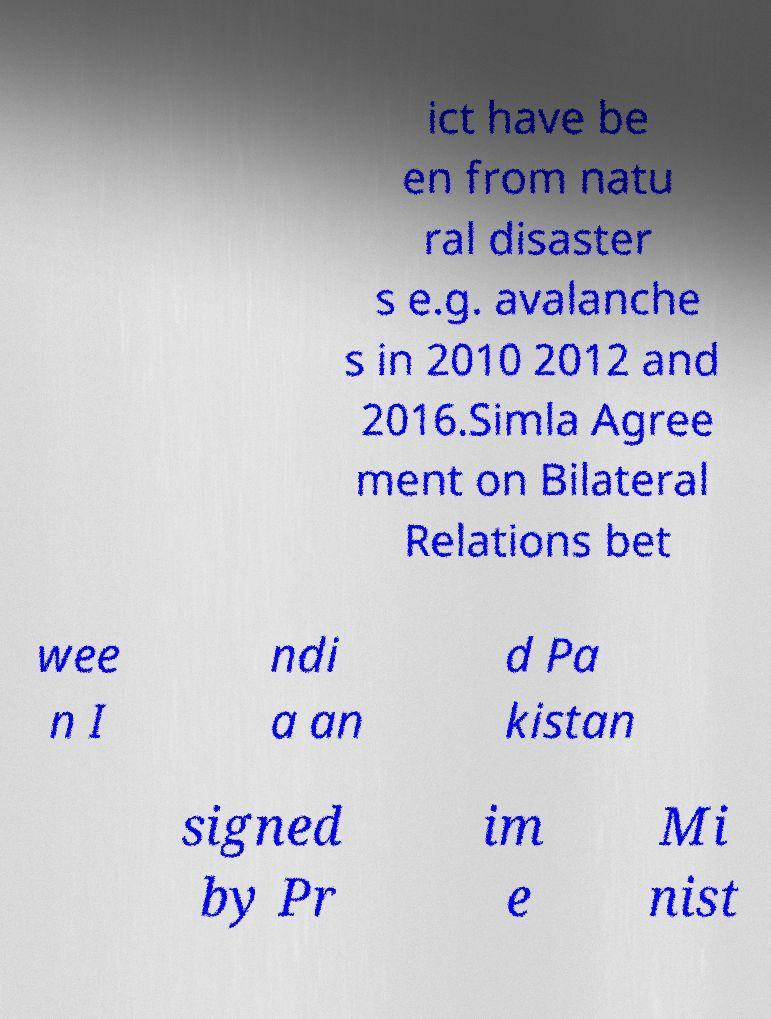What messages or text are displayed in this image? I need them in a readable, typed format. ict have be en from natu ral disaster s e.g. avalanche s in 2010 2012 and 2016.Simla Agree ment on Bilateral Relations bet wee n I ndi a an d Pa kistan signed by Pr im e Mi nist 